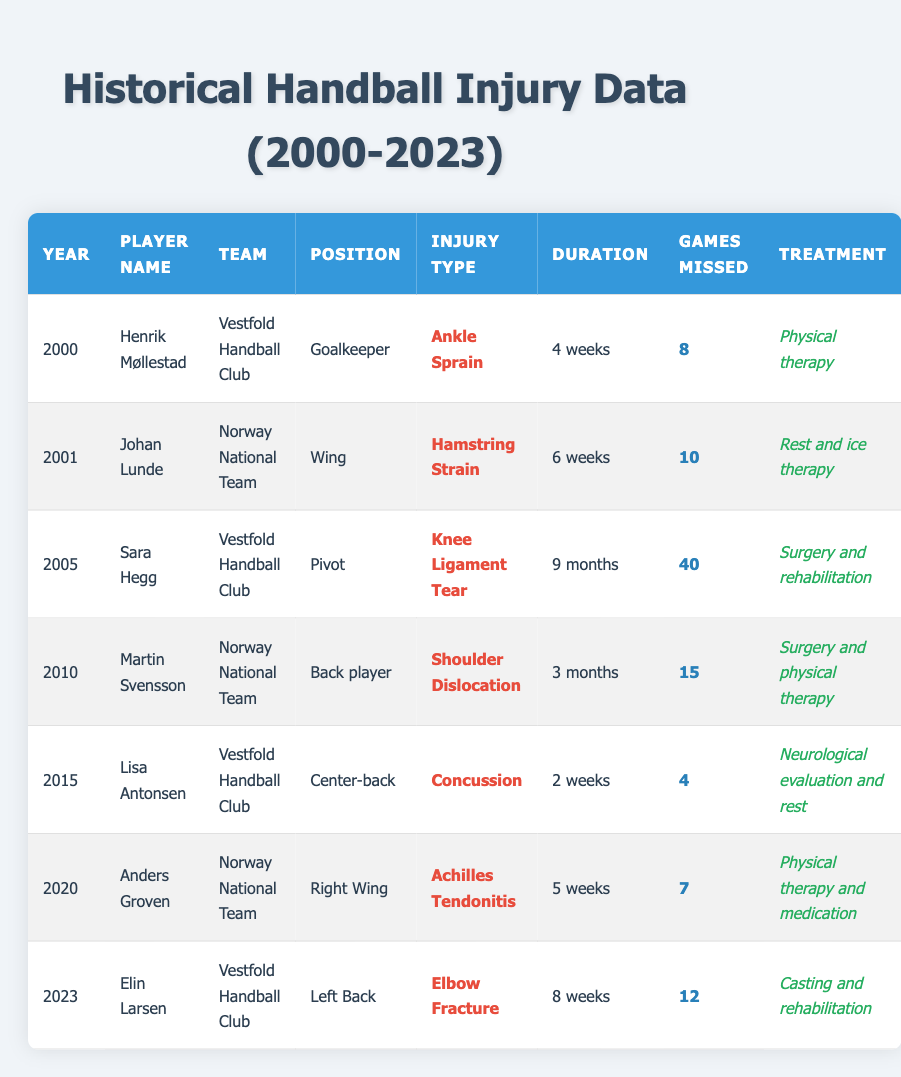What is the injury type for Henrik Møllestad? According to the table, Henrik Møllestad has an injury type listed as "Ankle Sprain" for the year 2000.
Answer: Ankle Sprain How many games did Johan Lunde miss due to his injury? The table indicates Johan Lunde missed a total of 10 games in 2001 due to a "Hamstring Strain."
Answer: 10 Which player had the longest recovery duration, and what was the duration? Sara Hegg had the longest recovery duration of 9 months due to a "Knee Ligament Tear" in 2005.
Answer: Sara Hegg, 9 months What treatment did Elin Larsen receive for her elbow fracture? The table states that Elin Larsen received "Casting and rehabilitation" for her injury in 2023.
Answer: Casting and rehabilitation In which year did Lisa Antonsen sustain her concussion and how long was her recovery? Lisa Antonsen sustained her concussion in 2015, and her recovery duration was "2 weeks."
Answer: 2015, 2 weeks What is the average number of games missed due to injuries among all players listed? To calculate the average, we first sum the games missed: 8 + 10 + 40 + 15 + 4 + 7 + 12 = 96. There are 7 players, so the average is 96/7 = approximately 13.71.
Answer: 13.71 Were any treatments purely based on rest or evaluation in the data? Yes, Lisa Antonsen's treatment for her concussion was "Neurological evaluation and rest," indicating a non-invasive approach.
Answer: Yes Which team had the most players listed in the injury data? The data shows that both "Vestfold Handball Club" and "Norway National Team" have 3 players listed. Therefore, both teams are tied.
Answer: Both teams tied, 3 players each How many total players experienced shoulder injuries from 2000 to 2023? From the table, only Martin Svensson in 2010 had a shoulder dislocation, so he is the only player noted for a shoulder injury within this timeframe.
Answer: 1 